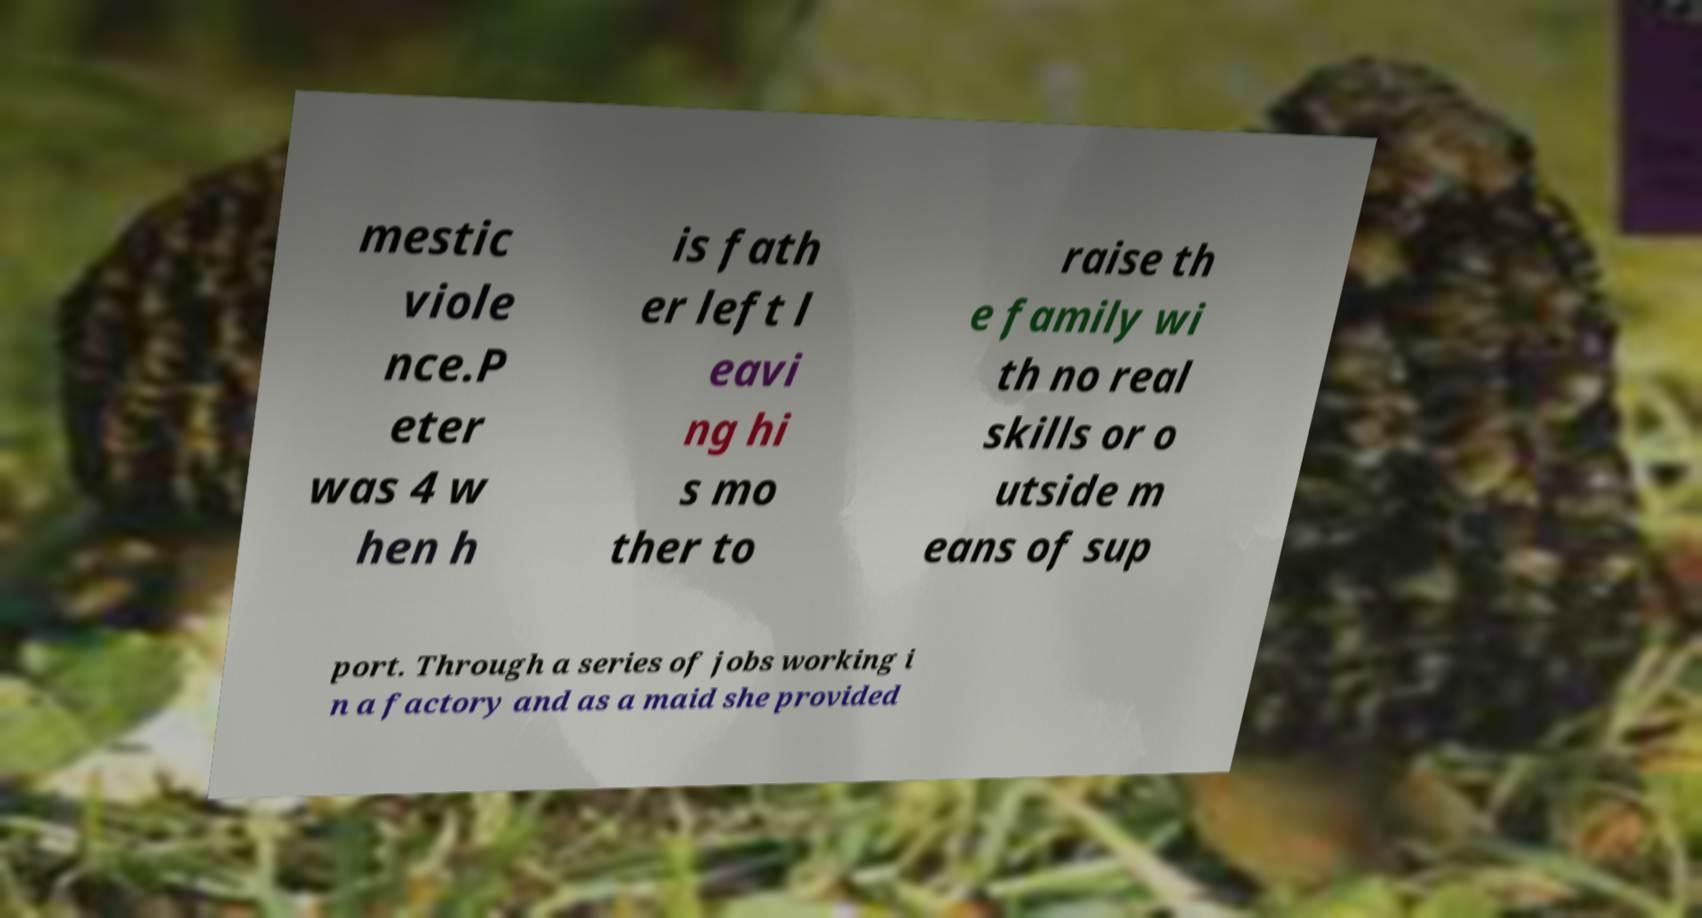Can you read and provide the text displayed in the image?This photo seems to have some interesting text. Can you extract and type it out for me? mestic viole nce.P eter was 4 w hen h is fath er left l eavi ng hi s mo ther to raise th e family wi th no real skills or o utside m eans of sup port. Through a series of jobs working i n a factory and as a maid she provided 